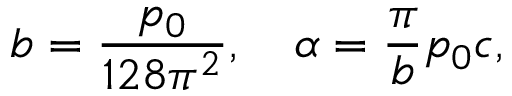Convert formula to latex. <formula><loc_0><loc_0><loc_500><loc_500>b = { \frac { p _ { 0 } } { 1 2 8 \pi ^ { 2 } } } , \quad \alpha = { \frac { \pi } { b } } p _ { 0 } c ,</formula> 